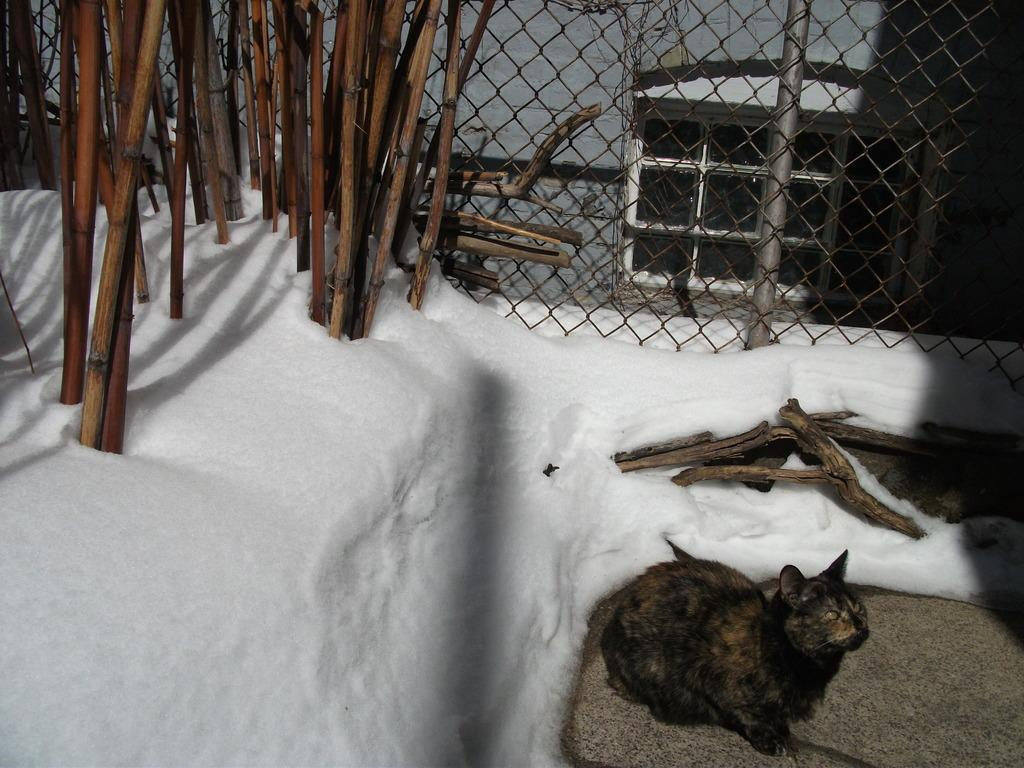What type of animal is in the image? There is a cat in the image. What objects are made of wood in the image? There are logs and sticks in the image. What can be seen in the background of the image? There is a mesh and a window on the wall in the background of the image. What type of weather is suggested by the image? There is snow at the bottom of the image, which suggests cold weather. What language is the cat speaking in the image? Cats do not speak human languages, so there is no language spoken by the cat in the image. 